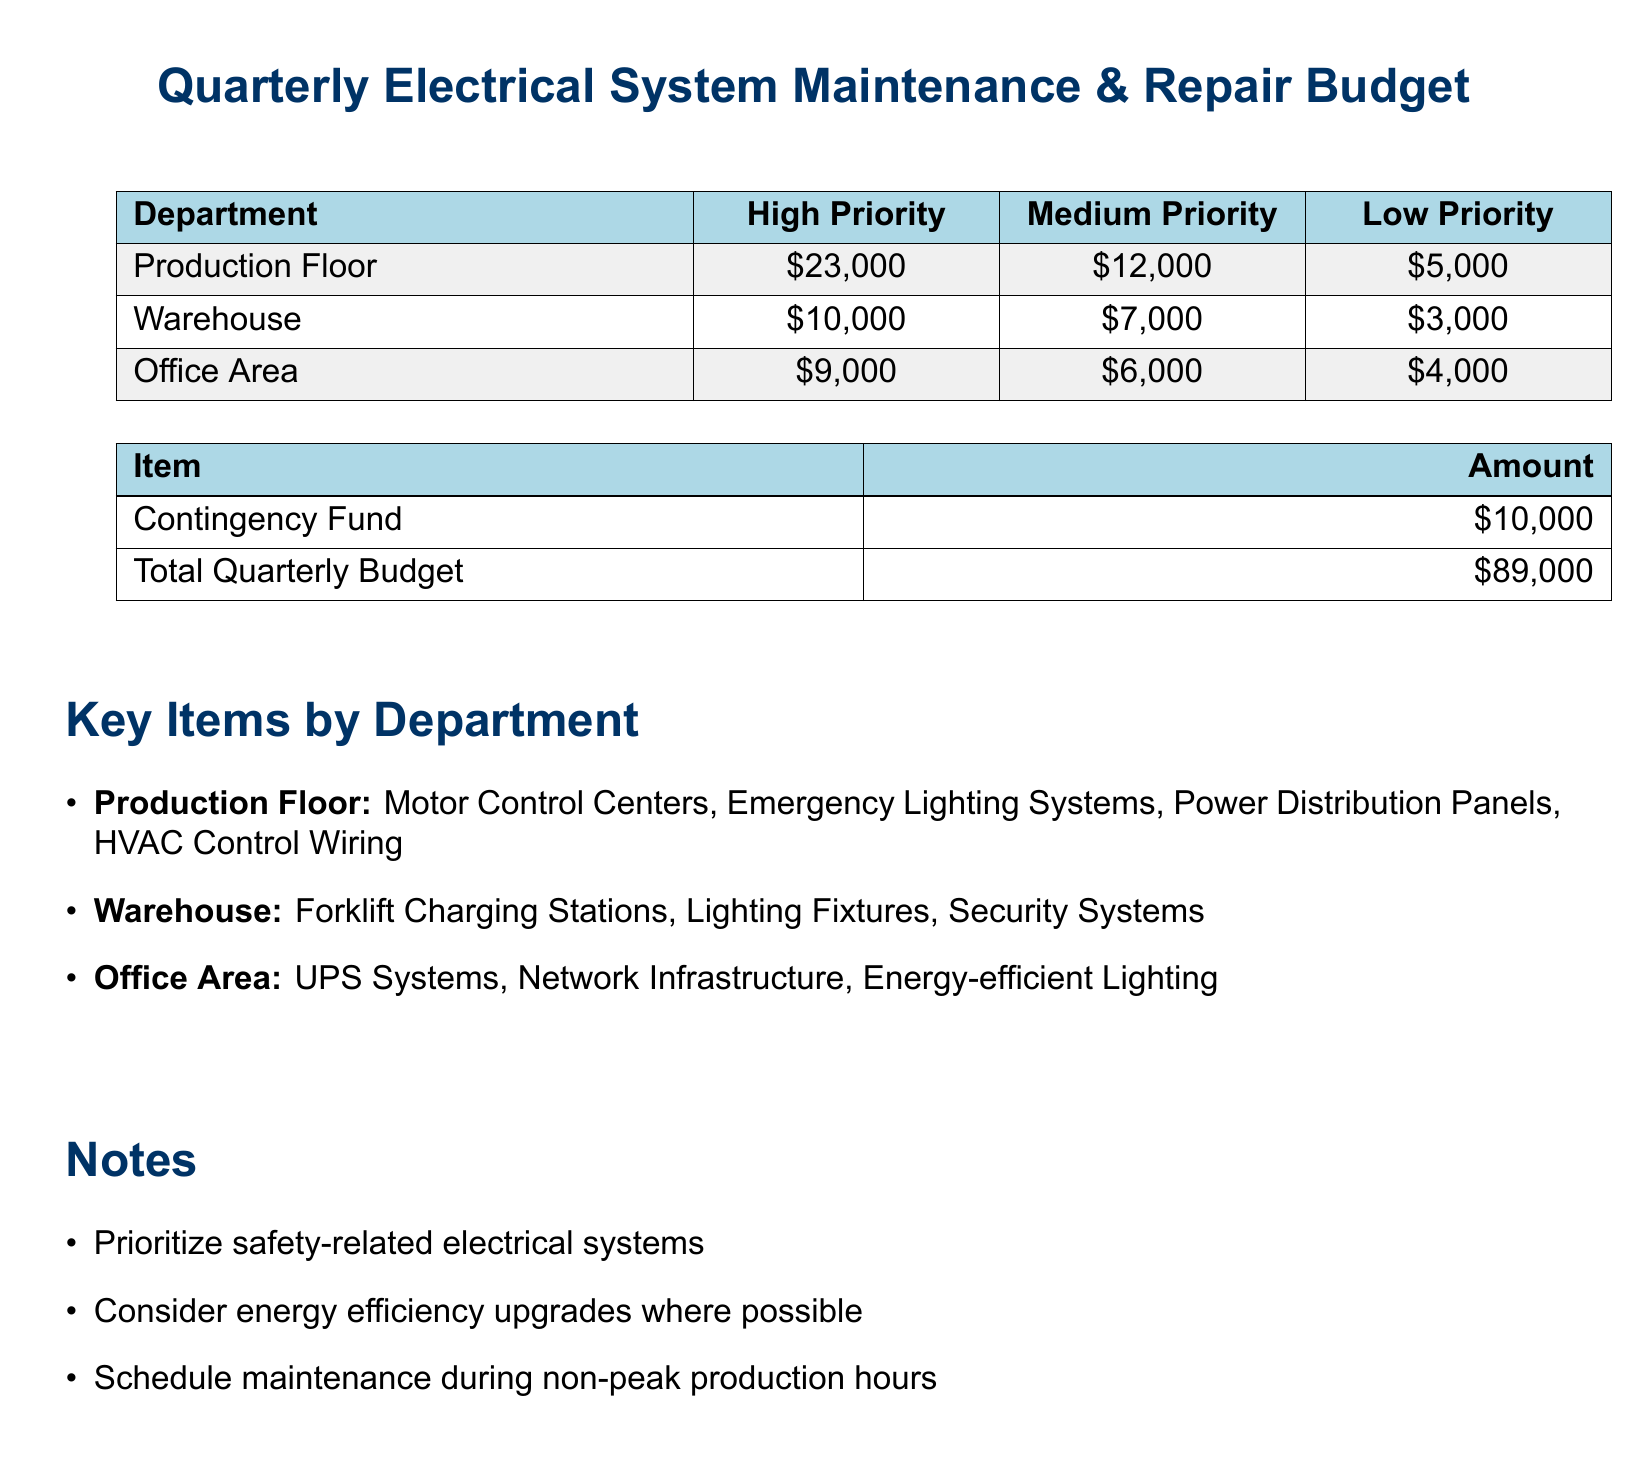what is the total quarterly budget? The total quarterly budget is stated in the document under the financial summary section.
Answer: $89,000 how much is allocated for high priority repairs in the Production Floor? The allocation for high priority repairs is listed in the department-specific budget table.
Answer: $23,000 which department has the lowest allocation for low priority repairs? This requires comparing low priority allocations across departments in the budget.
Answer: Warehouse what is the contingency fund amount? The contingency fund amount is mentioned in the financial summary section of the document.
Answer: $10,000 what item is prioritized for the Office Area? The key items by department section lists items for each department, focusing on the Office Area.
Answer: UPS Systems what is one priority noted for maintenance scheduling? The notes at the end of the document highlight specific scheduling considerations for maintenance.
Answer: Non-peak production hours how much is allocated for medium priority in the Warehouse? The medium priority amount is provided in the department-specific budget table.
Answer: $7,000 which department has the most allocated for high priority repairs? This involves looking at the high priority allocations in the budget to identify the department with the highest figure.
Answer: Production Floor what should be prioritized according to the notes section? The notes section lists safety considerations critical for maintenance and repair.
Answer: Safety-related electrical systems 